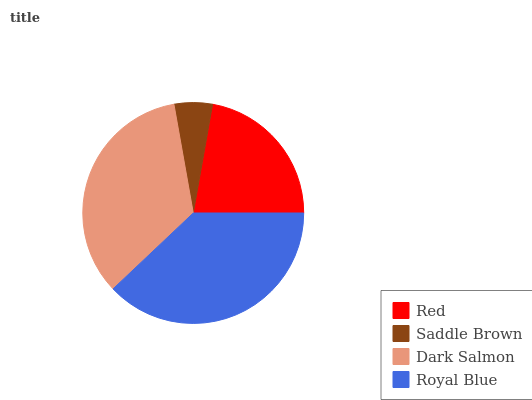Is Saddle Brown the minimum?
Answer yes or no. Yes. Is Royal Blue the maximum?
Answer yes or no. Yes. Is Dark Salmon the minimum?
Answer yes or no. No. Is Dark Salmon the maximum?
Answer yes or no. No. Is Dark Salmon greater than Saddle Brown?
Answer yes or no. Yes. Is Saddle Brown less than Dark Salmon?
Answer yes or no. Yes. Is Saddle Brown greater than Dark Salmon?
Answer yes or no. No. Is Dark Salmon less than Saddle Brown?
Answer yes or no. No. Is Dark Salmon the high median?
Answer yes or no. Yes. Is Red the low median?
Answer yes or no. Yes. Is Royal Blue the high median?
Answer yes or no. No. Is Dark Salmon the low median?
Answer yes or no. No. 